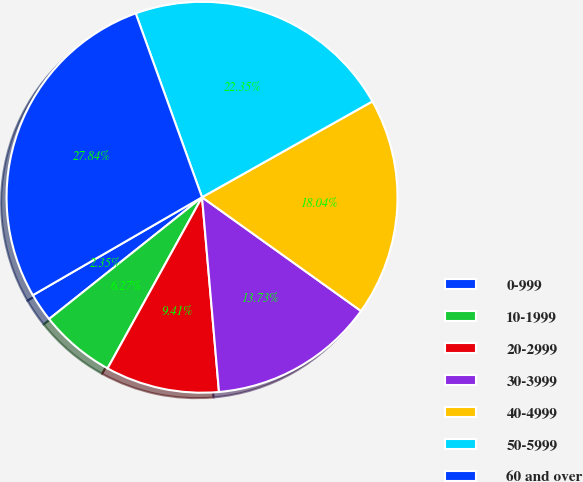Convert chart to OTSL. <chart><loc_0><loc_0><loc_500><loc_500><pie_chart><fcel>0-999<fcel>10-1999<fcel>20-2999<fcel>30-3999<fcel>40-4999<fcel>50-5999<fcel>60 and over<nl><fcel>2.35%<fcel>6.27%<fcel>9.41%<fcel>13.73%<fcel>18.04%<fcel>22.35%<fcel>27.84%<nl></chart> 